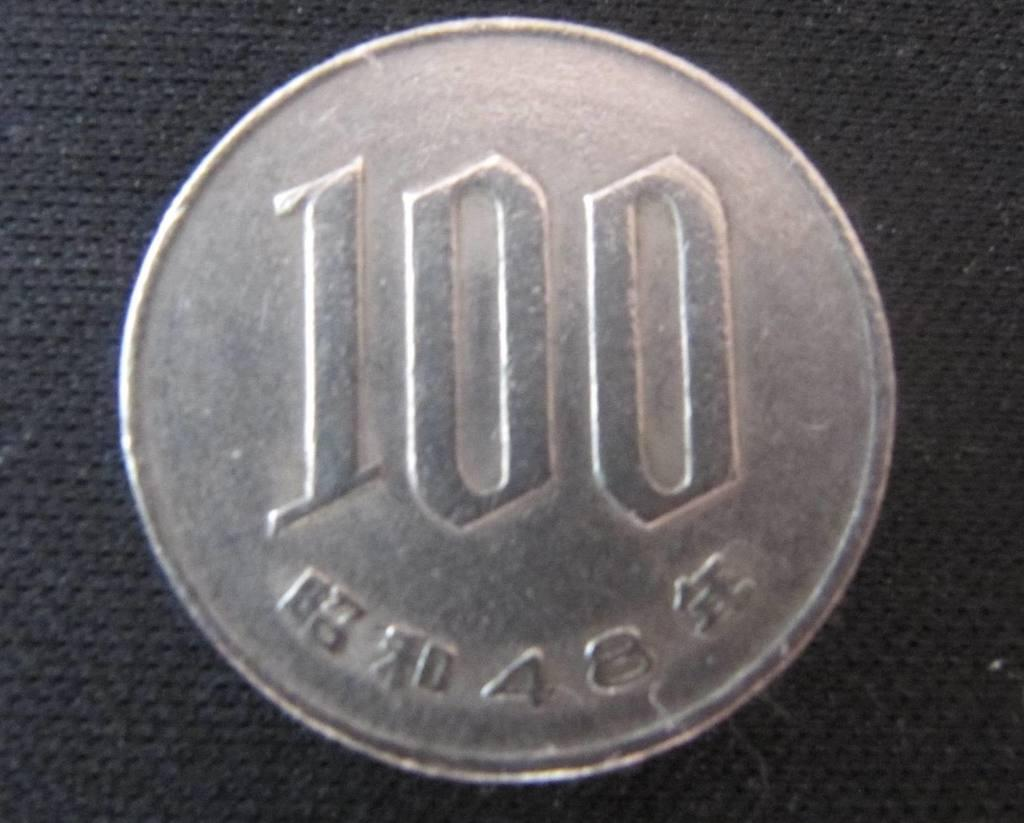Provide a one-sentence caption for the provided image. a silver coin that reads 100 and placed on the counter. 